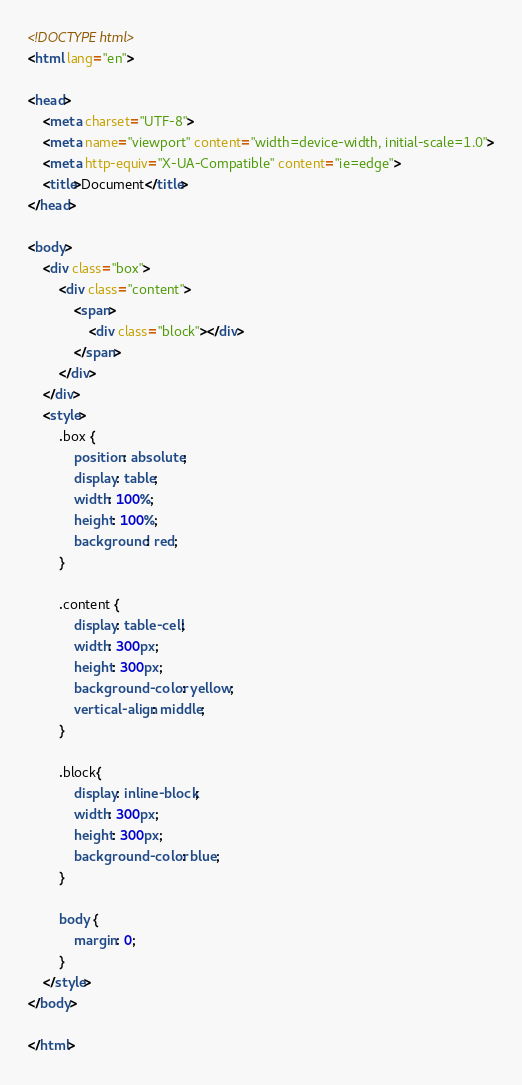Convert code to text. <code><loc_0><loc_0><loc_500><loc_500><_HTML_><!DOCTYPE html>
<html lang="en">

<head>
    <meta charset="UTF-8">
    <meta name="viewport" content="width=device-width, initial-scale=1.0">
    <meta http-equiv="X-UA-Compatible" content="ie=edge">
    <title>Document</title>
</head>

<body>
    <div class="box">
        <div class="content">
            <span>
                <div class="block"></div>
            </span>
        </div>
    </div>
    <style>
        .box {
            position: absolute;
            display: table;
            width: 100%;
            height: 100%;
            background: red;
        }

        .content {
            display: table-cell;
            width: 300px;
            height: 300px;
            background-color: yellow;
            vertical-align: middle;
        }

        .block{
            display: inline-block;
            width: 300px;
            height: 300px;
            background-color: blue;
        }

        body {
            margin: 0;
        }
    </style>
</body>

</html></code> 